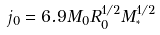<formula> <loc_0><loc_0><loc_500><loc_500>j _ { 0 } = 6 . 9 M _ { 0 } R _ { 0 } ^ { 1 / 2 } M _ { ^ { * } } ^ { 1 / 2 }</formula> 